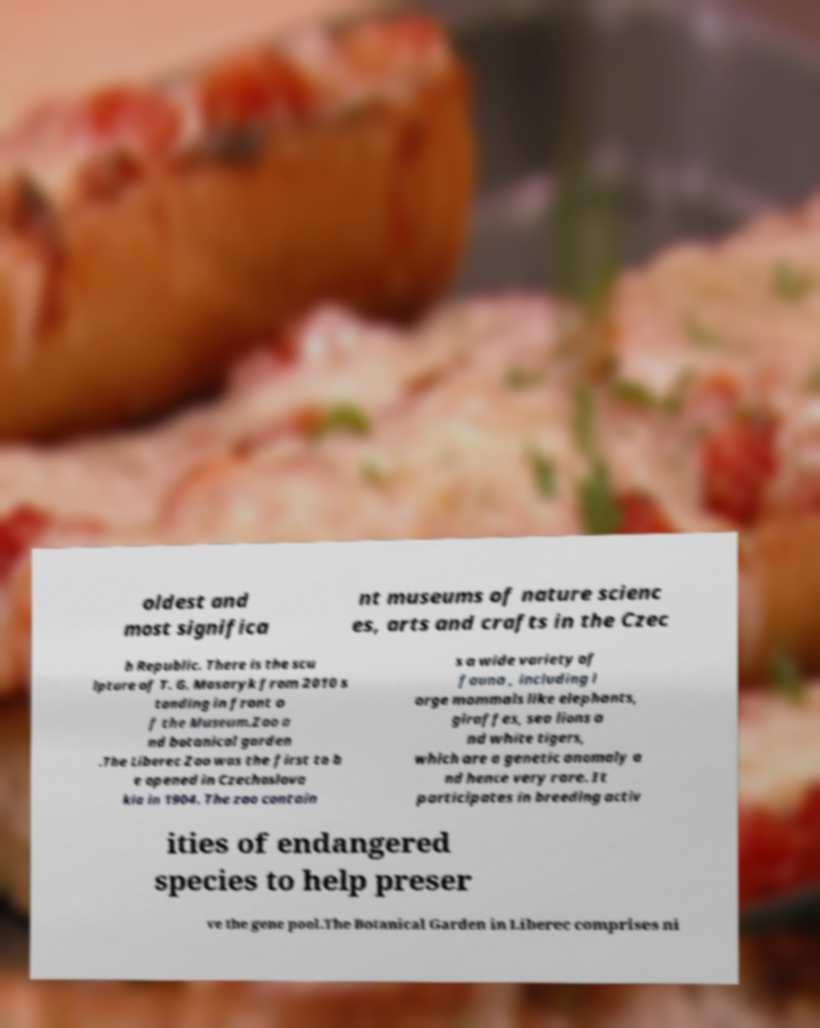Could you assist in decoding the text presented in this image and type it out clearly? oldest and most significa nt museums of nature scienc es, arts and crafts in the Czec h Republic. There is the scu lpture of T. G. Masaryk from 2010 s tanding in front o f the Museum.Zoo a nd botanical garden .The Liberec Zoo was the first to b e opened in Czechoslova kia in 1904. The zoo contain s a wide variety of fauna , including l arge mammals like elephants, giraffes, sea lions a nd white tigers, which are a genetic anomaly a nd hence very rare. It participates in breeding activ ities of endangered species to help preser ve the gene pool.The Botanical Garden in Liberec comprises ni 